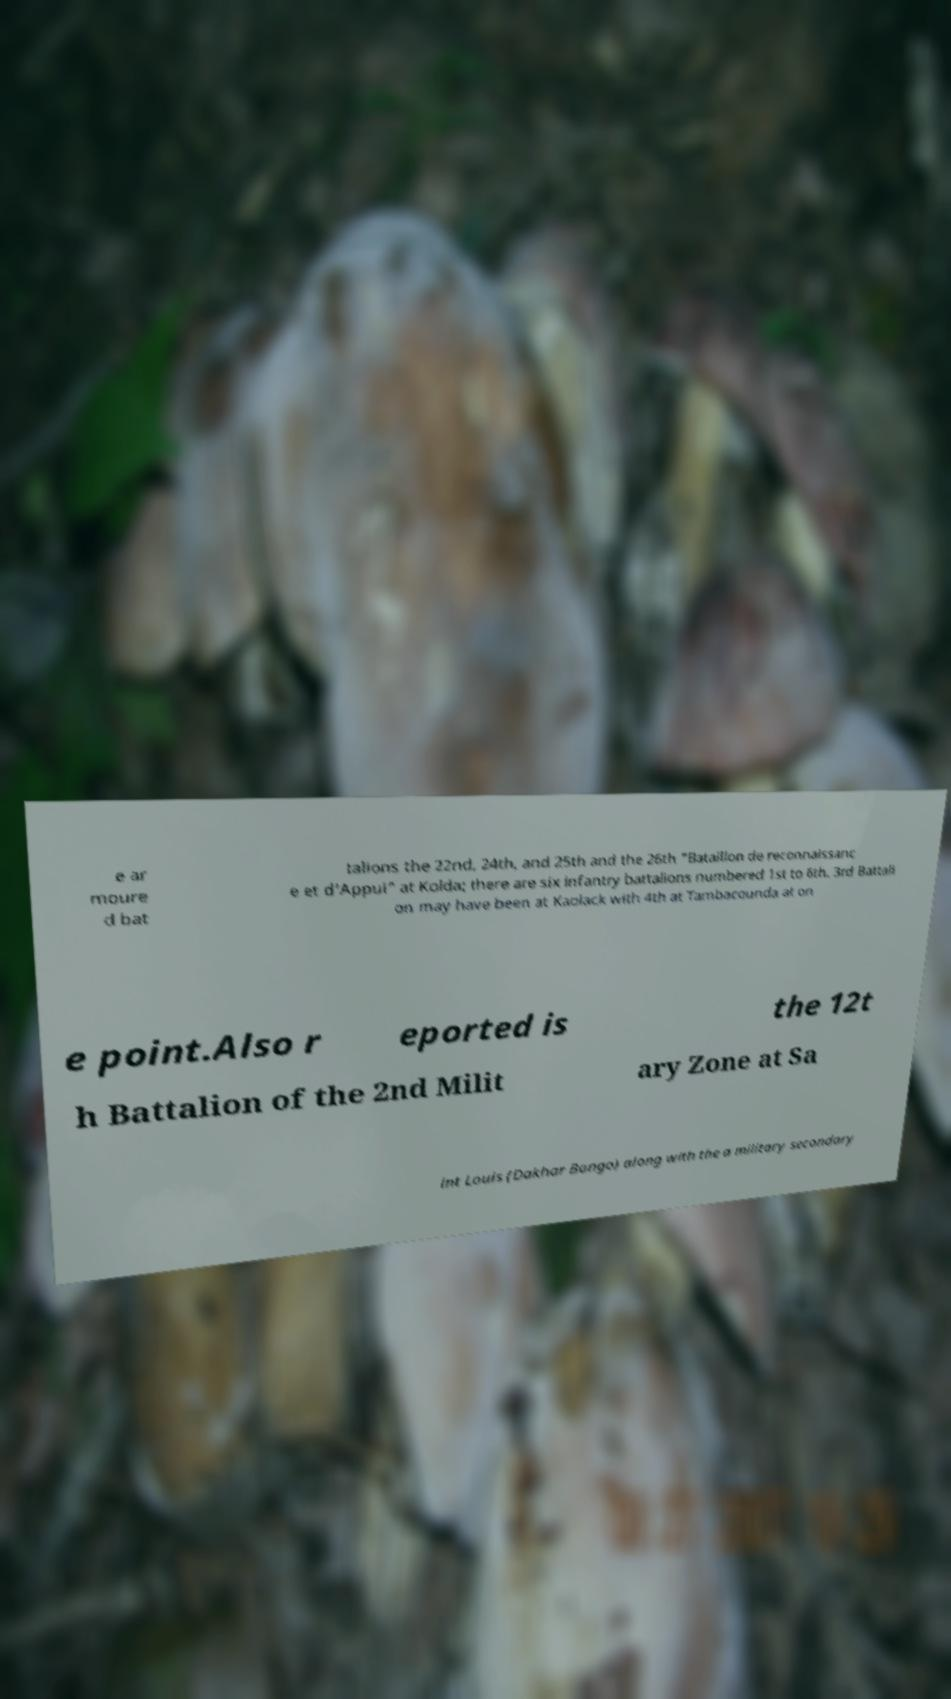What messages or text are displayed in this image? I need them in a readable, typed format. e ar moure d bat talions the 22nd, 24th, and 25th and the 26th "Bataillon de reconnaissanc e et d'Appui" at Kolda; there are six infantry battalions numbered 1st to 6th. 3rd Battali on may have been at Kaolack with 4th at Tambacounda at on e point.Also r eported is the 12t h Battalion of the 2nd Milit ary Zone at Sa int Louis (Dakhar Bango) along with the a military secondary 